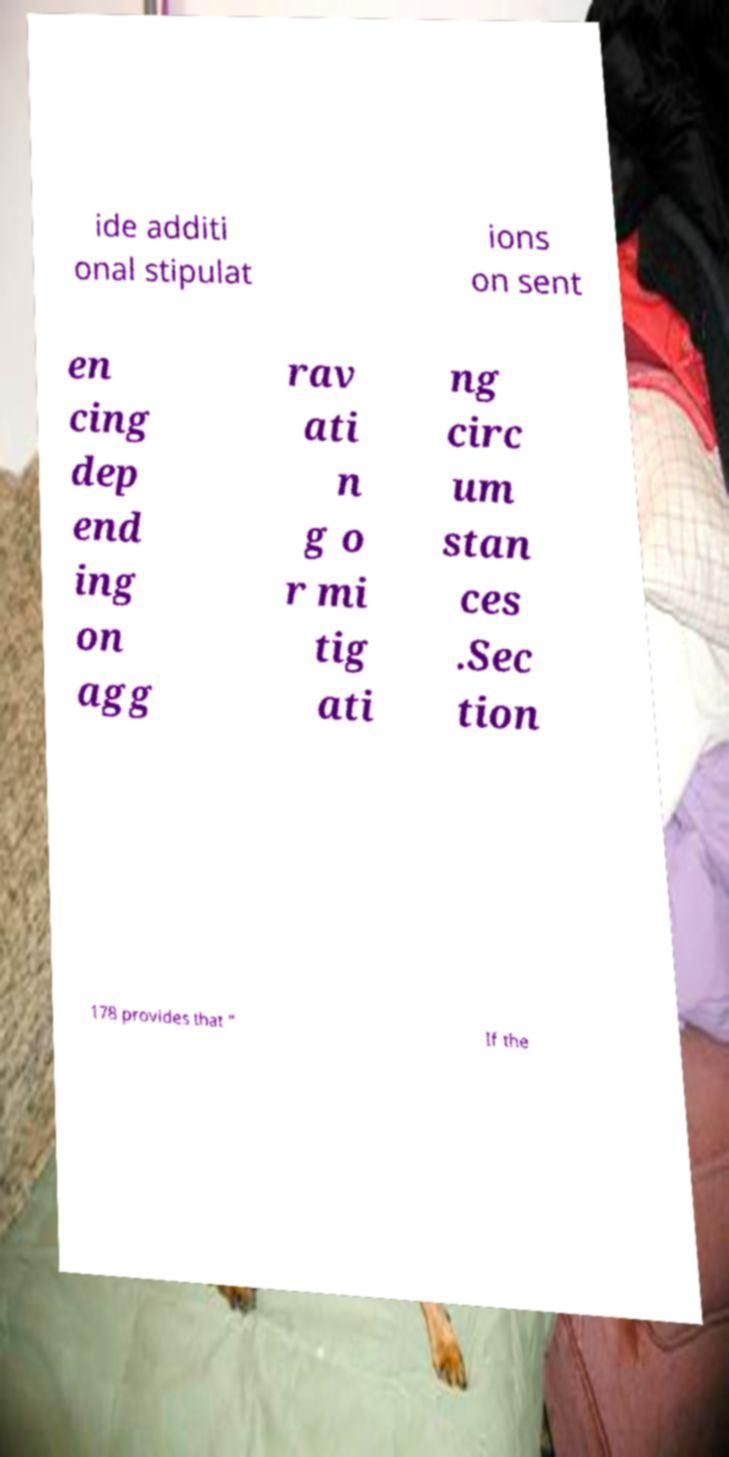Can you accurately transcribe the text from the provided image for me? ide additi onal stipulat ions on sent en cing dep end ing on agg rav ati n g o r mi tig ati ng circ um stan ces .Sec tion 178 provides that " If the 